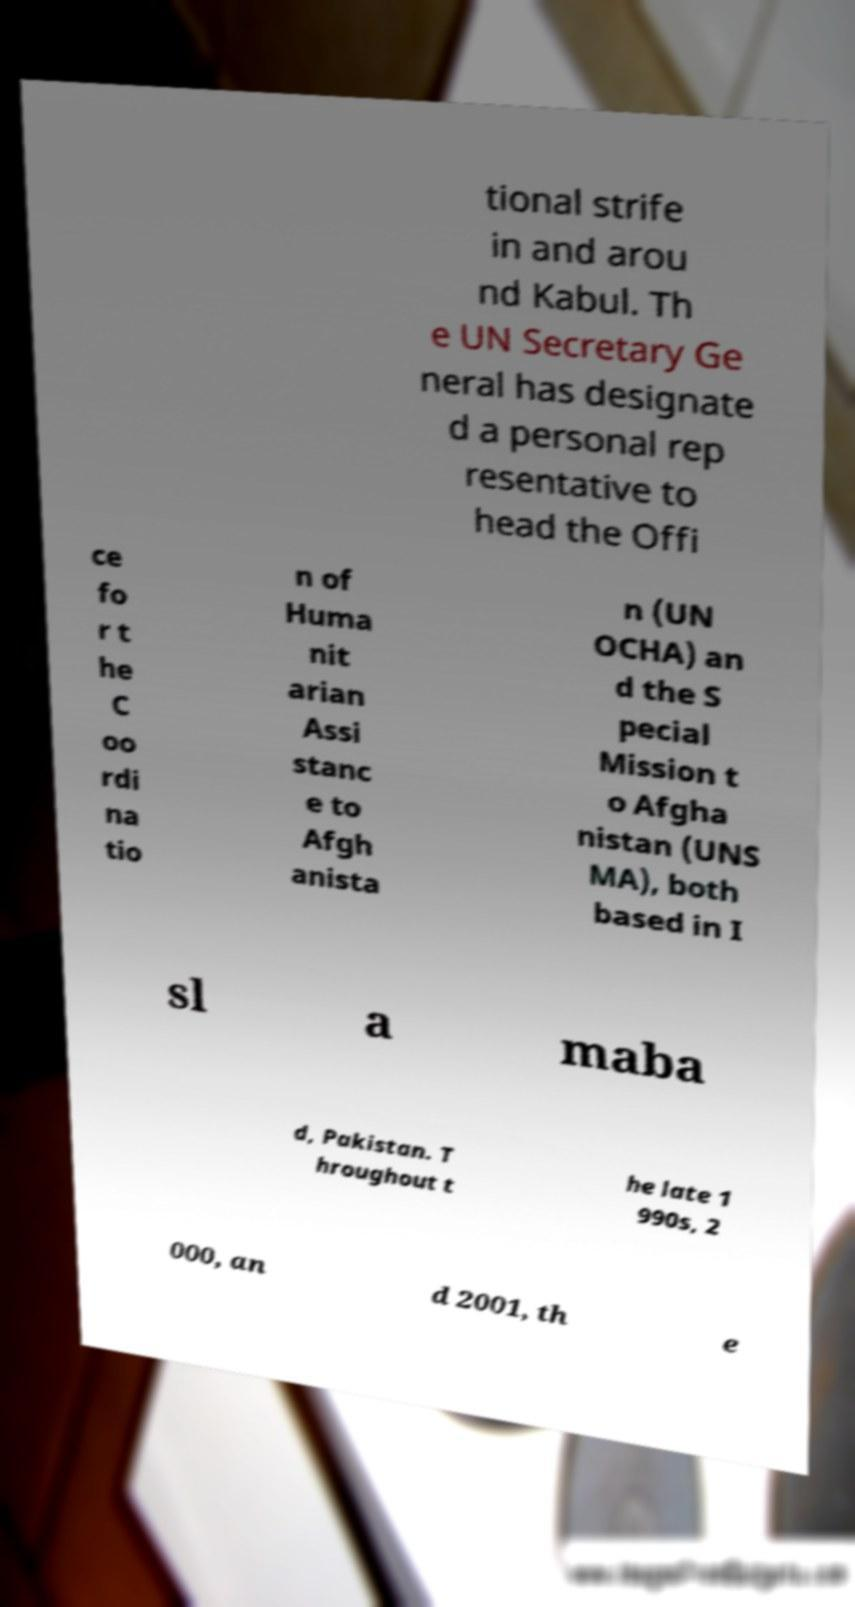For documentation purposes, I need the text within this image transcribed. Could you provide that? tional strife in and arou nd Kabul. Th e UN Secretary Ge neral has designate d a personal rep resentative to head the Offi ce fo r t he C oo rdi na tio n of Huma nit arian Assi stanc e to Afgh anista n (UN OCHA) an d the S pecial Mission t o Afgha nistan (UNS MA), both based in I sl a maba d, Pakistan. T hroughout t he late 1 990s, 2 000, an d 2001, th e 